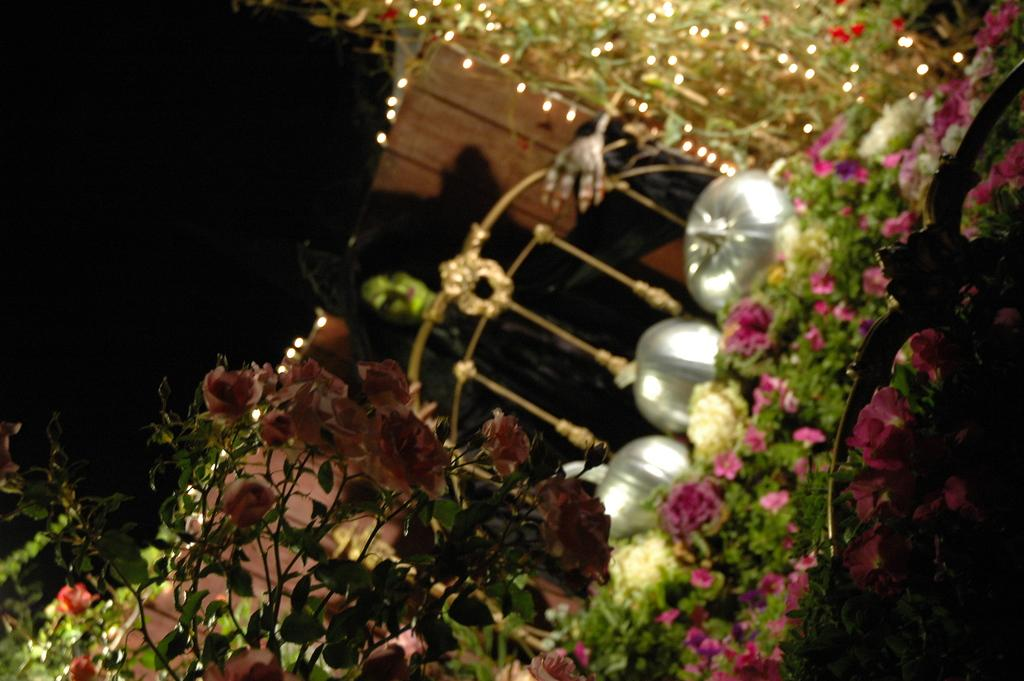What can be seen at the front of the image? There are flowers in the front of the image. What is located in the background of the image? There is a black color thing in the background of the image. What is visible at the top of the image? There are lights visible at the top of the image. Can you see a footprint on the flowers in the image? There is no mention of a footprint or any foot-related activity in the image. Is there anyone coughing in the image? There is no indication of anyone coughing or any sound-related activity in the image. 